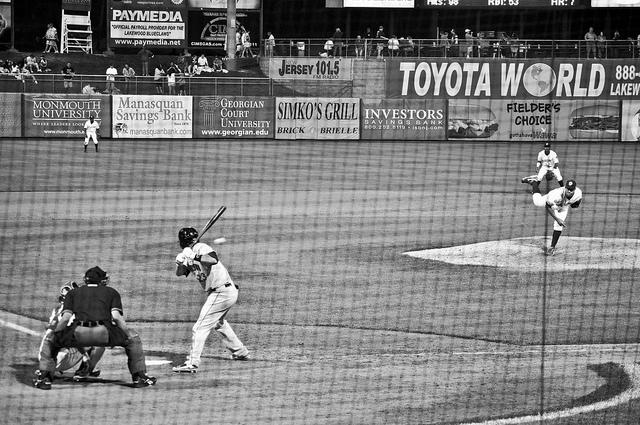What state is this field most likely in? new jersey 